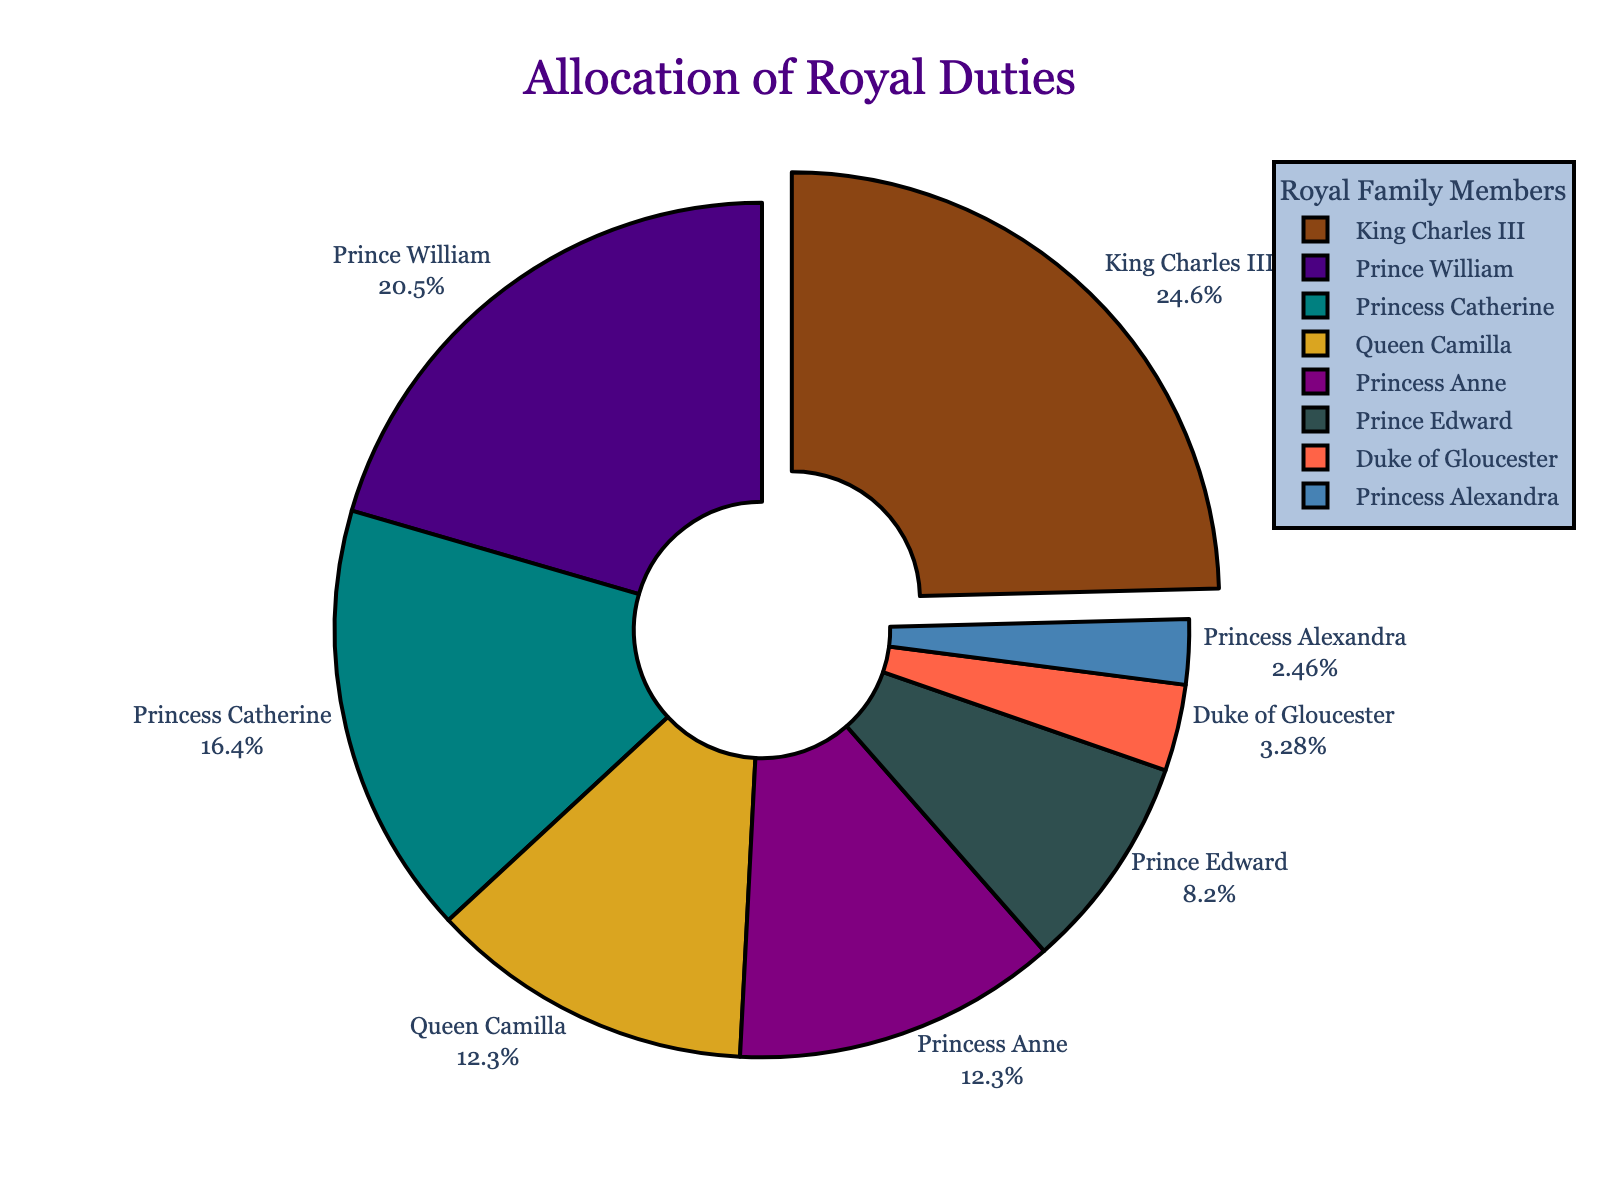What percentage of royal duties does Prince William handle? Look at the pie chart and find the section labeled "Prince William" and refer to its associated percentage.
Answer: 25% Who has the lowest allocation of royal duties? Identify the smallest slice in the pie chart and refer to its label, which indicates the member with the lowest percentage.
Answer: Princess Alexandra Who handles more royal duties, Queen Camilla or Princess Catherine? Compare the percentages associated with Queen Camilla and Princess Catherine from the pie chart. Queen Camilla has 15%, while Princess Catherine has 20%.
Answer: Princess Catherine What is the combined percentage of royal duties handled by Duke of Gloucester and Princess Alexandra? Add the percentages of the two members. Duke of Gloucester has 4% and Princess Alexandra has 3%. 4% + 3% = 7%
Answer: 7% What is the difference in the allocation of royal duties between King Charles III and Prince Edward? Subtract the percentage of Prince Edward from that of King Charles III. King Charles III has 30%, and Prince Edward has 10%. 30% - 10% = 20%
Answer: 20% Who are the members with an equal allocation of royal duties? Identify the sections in the pie chart that have the same size and refer to their labels.
Answer: Queen Camilla and Princess Anne Which member is pulled out the most in the pie chart, and what is the reason for this pull? The section that appears pulled out the most is an indicator provided in the pie chart as the member with the maximum percentage. King Charles III's section is pulled out the most due to his highest allocation at 30%.
Answer: King Charles III, due to highest allocation What is the color associated with Princess Catherine's section? Refer to the legend or the color of the section labeled "Princess Catherine" in the pie chart.
Answer: Green Calculate the average percentage of royal duties allocated to Princess Anne, Prince Edward, and Duke of Gloucester. Add their percentages and divide by the number of members. Princess Anne has 15%, Prince Edward has 10%, and Duke of Gloucester has 4%. (15% + 10% + 4%) / 3 = 9.67%
Answer: 9.67% How many members handle more than 20% of the royal duties? Identify the members in the pie chart whose allocated duties are greater than 20% and count them. King Charles III has 30%, and Prince William has 25%.
Answer: 2 